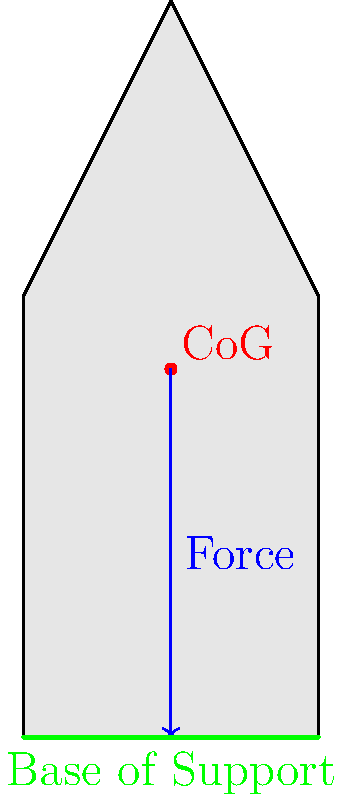In the diagram above, which represents a basic body outline of a toddler during early walking attempts, what change to the center of gravity (CoG) position would likely improve the child's balance?

A) Moving the CoG higher
B) Moving the CoG lower
C) Moving the CoG to the left
D) Moving the CoG to the right To understand the correct answer, let's break down the biomechanics of balance in early walking:

1. The center of gravity (CoG) is the point where the body's mass is concentrated, represented by the red dot in the diagram.

2. Balance is maintained when the CoG is positioned directly above the base of support (BoS), which is the area between the feet (green line in the diagram).

3. The blue arrow represents the force vector of gravity acting on the CoG.

4. In early walking, toddlers often have a high CoG relative to their BoS, which makes balancing more challenging.

5. Lowering the CoG would bring it closer to the BoS, making it easier to maintain balance. This is why toddlers often walk with bent knees and a wider stance.

6. Moving the CoG horizontally (left or right) would not significantly improve balance, as it would still be at the same height relative to the BoS.

7. Raising the CoG would make balance even more difficult, as it would increase the distance between the CoG and the BoS.

Therefore, the most effective way to improve balance would be to lower the CoG, bringing it closer to the base of support.
Answer: B) Moving the CoG lower 